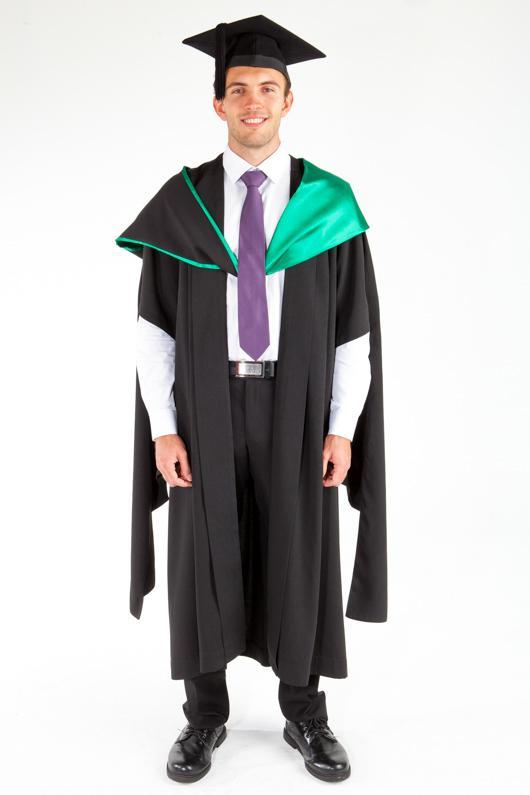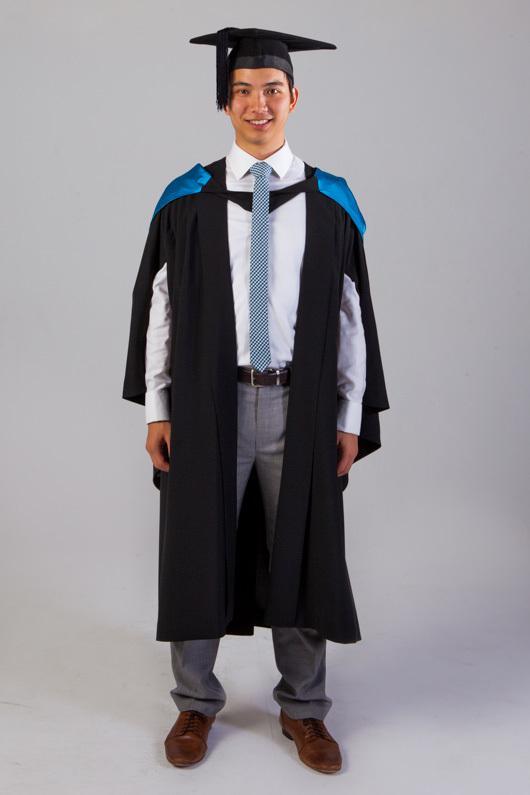The first image is the image on the left, the second image is the image on the right. Examine the images to the left and right. Is the description "An image shows male modeling back and front views of graduation garb." accurate? Answer yes or no. No. The first image is the image on the left, the second image is the image on the right. For the images shown, is this caption "there is exactly one person in the image on the left" true? Answer yes or no. Yes. 